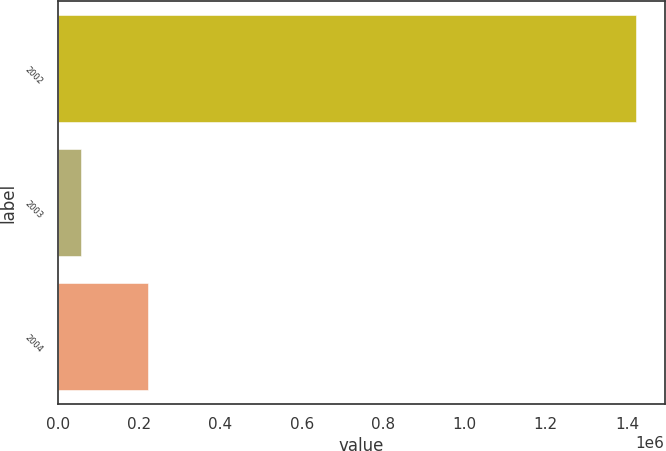Convert chart to OTSL. <chart><loc_0><loc_0><loc_500><loc_500><bar_chart><fcel>2002<fcel>2003<fcel>2004<nl><fcel>1.42083e+06<fcel>58343<fcel>222593<nl></chart> 